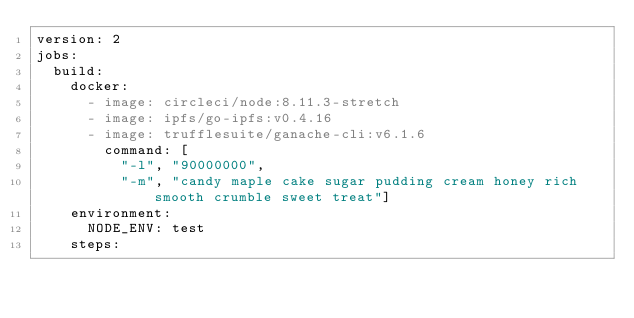Convert code to text. <code><loc_0><loc_0><loc_500><loc_500><_YAML_>version: 2
jobs:
  build:
    docker:
      - image: circleci/node:8.11.3-stretch
      - image: ipfs/go-ipfs:v0.4.16
      - image: trufflesuite/ganache-cli:v6.1.6
        command: [
          "-l", "90000000",
          "-m", "candy maple cake sugar pudding cream honey rich smooth crumble sweet treat"]
    environment:
      NODE_ENV: test
    steps:</code> 